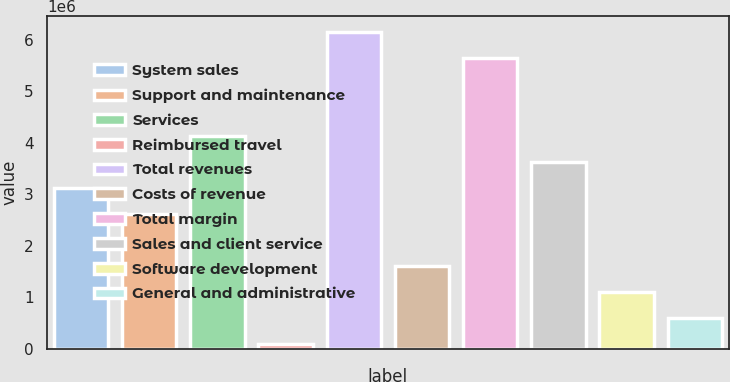Convert chart to OTSL. <chart><loc_0><loc_0><loc_500><loc_500><bar_chart><fcel>System sales<fcel>Support and maintenance<fcel>Services<fcel>Reimbursed travel<fcel>Total revenues<fcel>Costs of revenue<fcel>Total margin<fcel>Sales and client service<fcel>Software development<fcel>General and administrative<nl><fcel>3.12595e+06<fcel>2.62187e+06<fcel>4.13411e+06<fcel>101463<fcel>6.15043e+06<fcel>1.61371e+06<fcel>5.64635e+06<fcel>3.63003e+06<fcel>1.10962e+06<fcel>605544<nl></chart> 